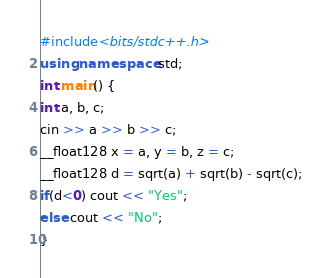<code> <loc_0><loc_0><loc_500><loc_500><_C++_>#include<bits/stdc++.h>
using namespace std;
int main() {
int a, b, c;
cin >> a >> b >> c;
__float128 x = a, y = b, z = c;
__float128 d = sqrt(a) + sqrt(b) - sqrt(c);
if(d<0) cout << "Yes";
else cout << "No";
}</code> 